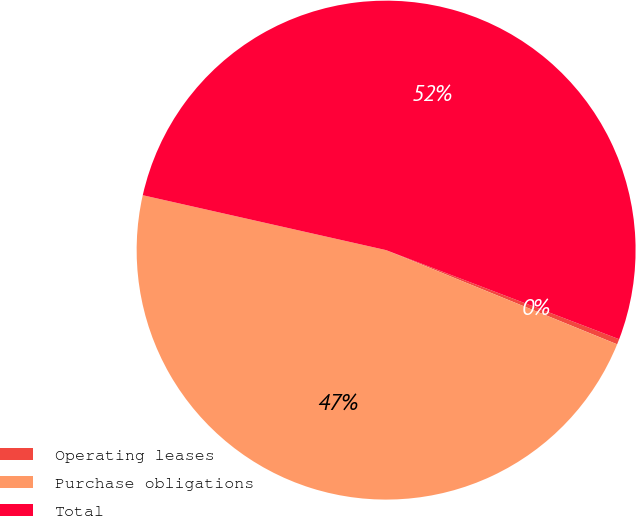Convert chart. <chart><loc_0><loc_0><loc_500><loc_500><pie_chart><fcel>Operating leases<fcel>Purchase obligations<fcel>Total<nl><fcel>0.35%<fcel>47.37%<fcel>52.28%<nl></chart> 